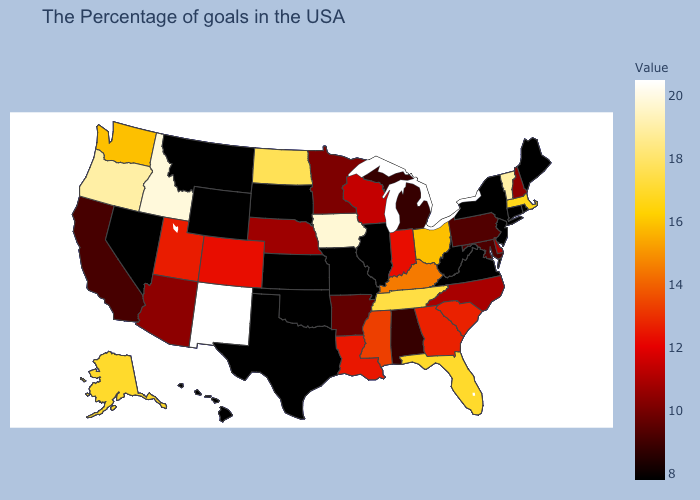Does the map have missing data?
Be succinct. No. Which states have the highest value in the USA?
Give a very brief answer. New Mexico. Among the states that border Delaware , does New Jersey have the lowest value?
Quick response, please. Yes. 